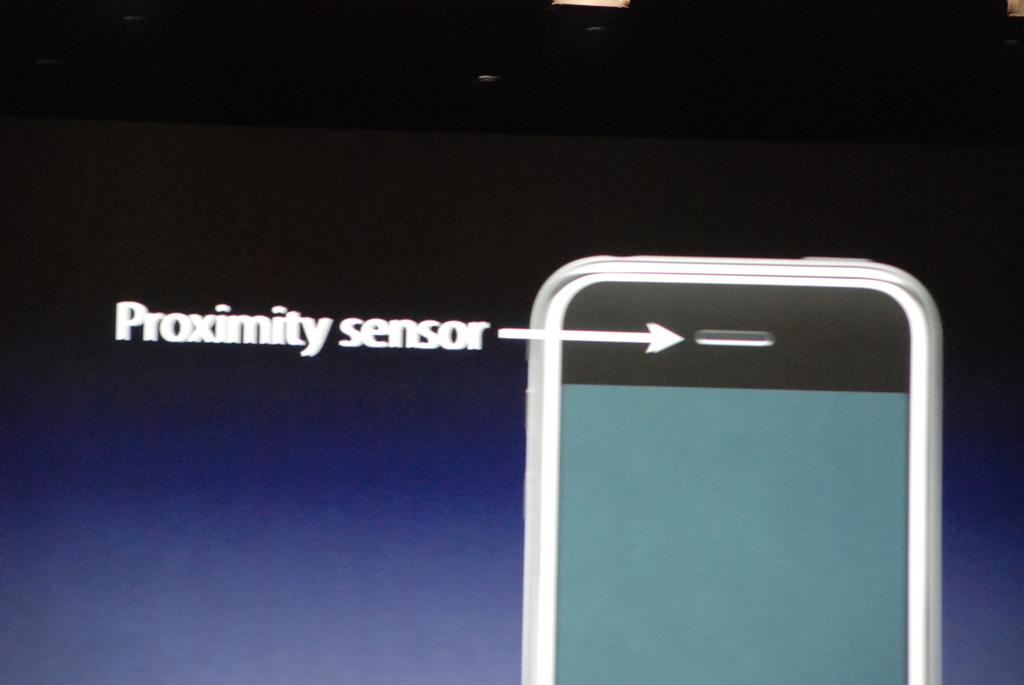What is the arrow pointing at?
Your answer should be compact. Proximity sensor. What kind of sensor?
Offer a terse response. Proximity. 